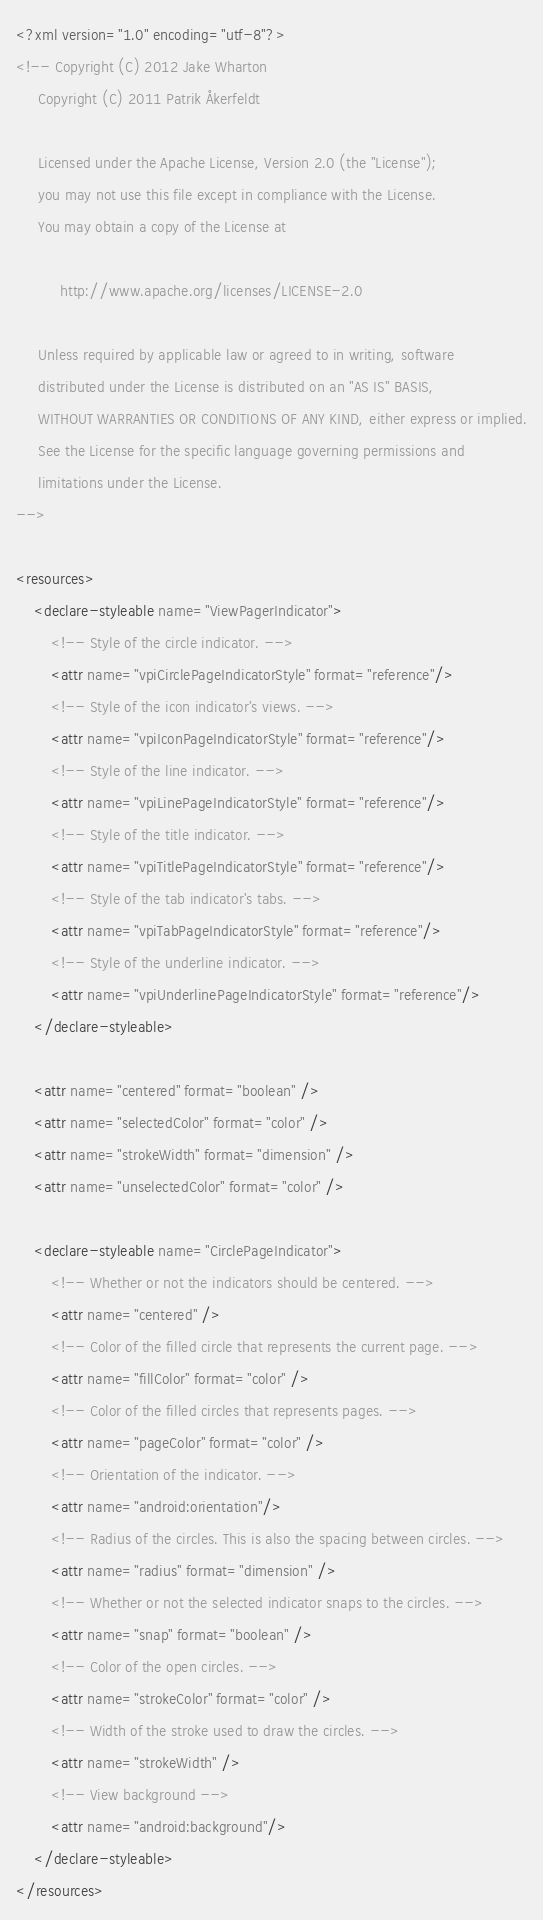Convert code to text. <code><loc_0><loc_0><loc_500><loc_500><_XML_><?xml version="1.0" encoding="utf-8"?>
<!-- Copyright (C) 2012 Jake Wharton
     Copyright (C) 2011 Patrik Åkerfeldt

     Licensed under the Apache License, Version 2.0 (the "License");
     you may not use this file except in compliance with the License.
     You may obtain a copy of the License at

          http://www.apache.org/licenses/LICENSE-2.0

     Unless required by applicable law or agreed to in writing, software
     distributed under the License is distributed on an "AS IS" BASIS,
     WITHOUT WARRANTIES OR CONDITIONS OF ANY KIND, either express or implied.
     See the License for the specific language governing permissions and
     limitations under the License.
-->

<resources>
    <declare-styleable name="ViewPagerIndicator">
        <!-- Style of the circle indicator. -->
        <attr name="vpiCirclePageIndicatorStyle" format="reference"/>
        <!-- Style of the icon indicator's views. -->
        <attr name="vpiIconPageIndicatorStyle" format="reference"/>
        <!-- Style of the line indicator. -->
        <attr name="vpiLinePageIndicatorStyle" format="reference"/>
        <!-- Style of the title indicator. -->
        <attr name="vpiTitlePageIndicatorStyle" format="reference"/>
        <!-- Style of the tab indicator's tabs. -->
        <attr name="vpiTabPageIndicatorStyle" format="reference"/>
        <!-- Style of the underline indicator. -->
        <attr name="vpiUnderlinePageIndicatorStyle" format="reference"/>
    </declare-styleable>

    <attr name="centered" format="boolean" />
    <attr name="selectedColor" format="color" />
    <attr name="strokeWidth" format="dimension" />
    <attr name="unselectedColor" format="color" />

    <declare-styleable name="CirclePageIndicator">
        <!-- Whether or not the indicators should be centered. -->
        <attr name="centered" />
        <!-- Color of the filled circle that represents the current page. -->
        <attr name="fillColor" format="color" />
        <!-- Color of the filled circles that represents pages. -->
        <attr name="pageColor" format="color" />
        <!-- Orientation of the indicator. -->
        <attr name="android:orientation"/>
        <!-- Radius of the circles. This is also the spacing between circles. -->
        <attr name="radius" format="dimension" />
        <!-- Whether or not the selected indicator snaps to the circles. -->
        <attr name="snap" format="boolean" />
        <!-- Color of the open circles. -->
        <attr name="strokeColor" format="color" />
        <!-- Width of the stroke used to draw the circles. -->
        <attr name="strokeWidth" />
        <!-- View background -->
        <attr name="android:background"/>
    </declare-styleable>
</resources>
</code> 